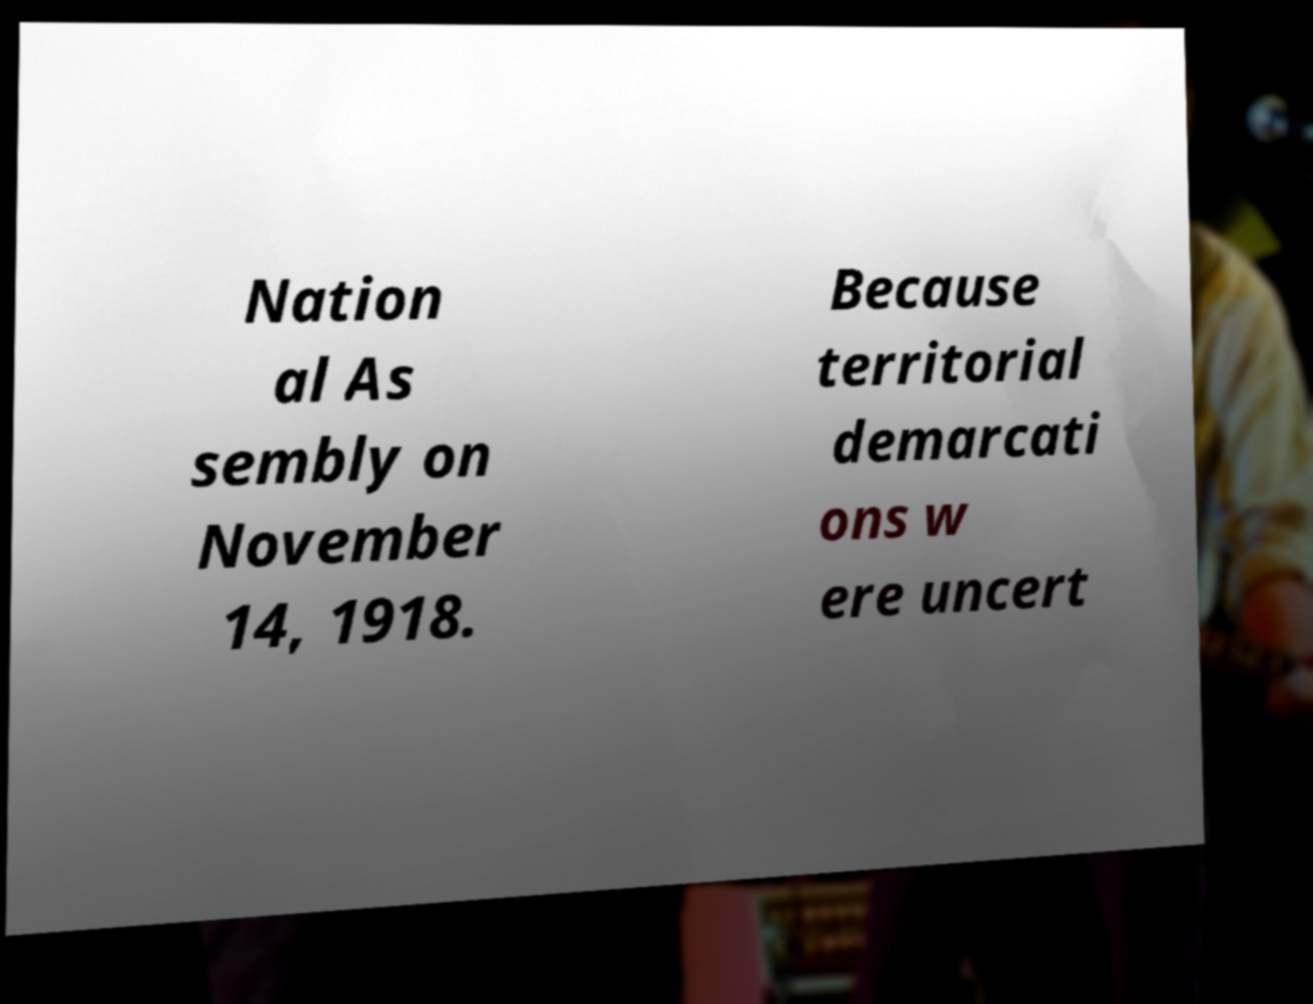I need the written content from this picture converted into text. Can you do that? Nation al As sembly on November 14, 1918. Because territorial demarcati ons w ere uncert 